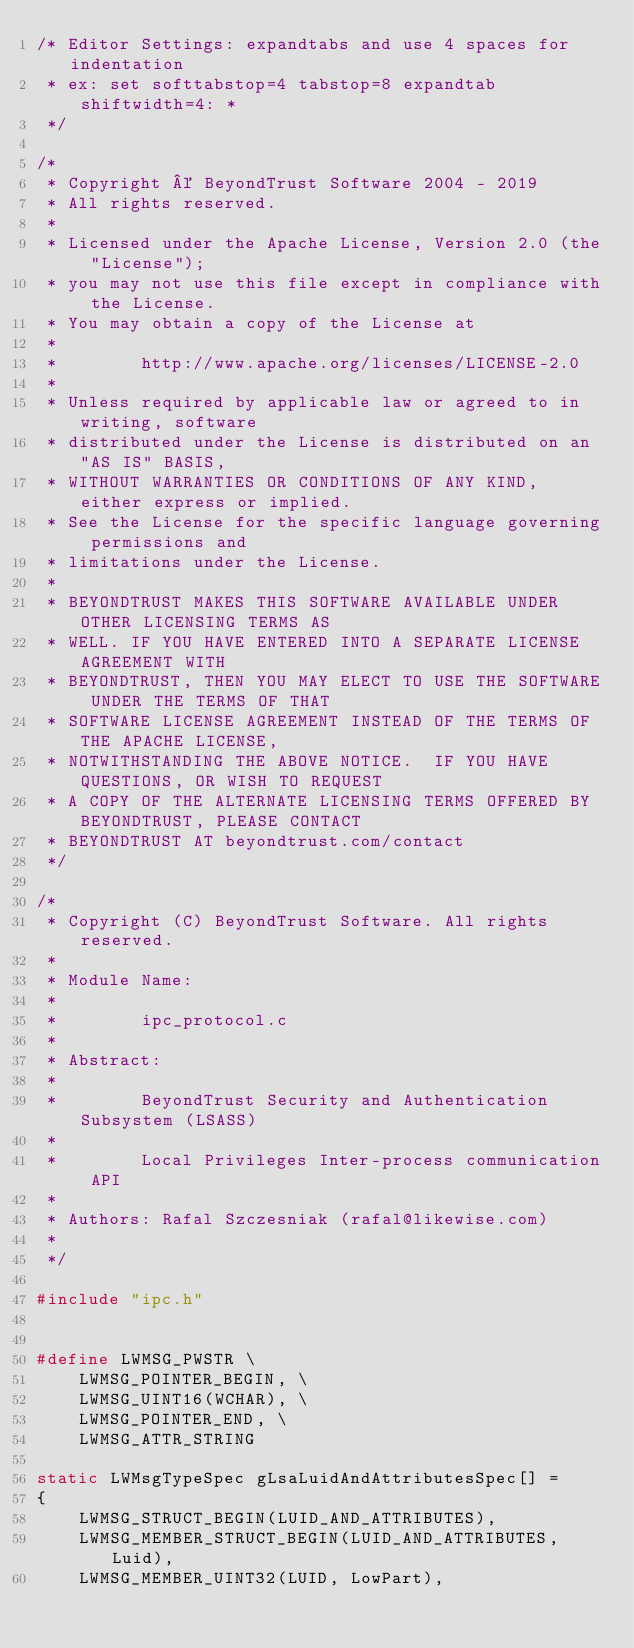Convert code to text. <code><loc_0><loc_0><loc_500><loc_500><_C_>/* Editor Settings: expandtabs and use 4 spaces for indentation
 * ex: set softtabstop=4 tabstop=8 expandtab shiftwidth=4: *
 */

/*
 * Copyright © BeyondTrust Software 2004 - 2019
 * All rights reserved.
 *
 * Licensed under the Apache License, Version 2.0 (the "License");
 * you may not use this file except in compliance with the License.
 * You may obtain a copy of the License at
 *
 *        http://www.apache.org/licenses/LICENSE-2.0
 *
 * Unless required by applicable law or agreed to in writing, software
 * distributed under the License is distributed on an "AS IS" BASIS,
 * WITHOUT WARRANTIES OR CONDITIONS OF ANY KIND, either express or implied.
 * See the License for the specific language governing permissions and
 * limitations under the License.
 *
 * BEYONDTRUST MAKES THIS SOFTWARE AVAILABLE UNDER OTHER LICENSING TERMS AS
 * WELL. IF YOU HAVE ENTERED INTO A SEPARATE LICENSE AGREEMENT WITH
 * BEYONDTRUST, THEN YOU MAY ELECT TO USE THE SOFTWARE UNDER THE TERMS OF THAT
 * SOFTWARE LICENSE AGREEMENT INSTEAD OF THE TERMS OF THE APACHE LICENSE,
 * NOTWITHSTANDING THE ABOVE NOTICE.  IF YOU HAVE QUESTIONS, OR WISH TO REQUEST
 * A COPY OF THE ALTERNATE LICENSING TERMS OFFERED BY BEYONDTRUST, PLEASE CONTACT
 * BEYONDTRUST AT beyondtrust.com/contact
 */

/*
 * Copyright (C) BeyondTrust Software. All rights reserved.
 *
 * Module Name:
 *
 *        ipc_protocol.c
 *
 * Abstract:
 *
 *        BeyondTrust Security and Authentication Subsystem (LSASS)
 *
 *        Local Privileges Inter-process communication API
 *
 * Authors: Rafal Szczesniak (rafal@likewise.com)
 *
 */

#include "ipc.h"


#define LWMSG_PWSTR \
    LWMSG_POINTER_BEGIN, \
    LWMSG_UINT16(WCHAR), \
    LWMSG_POINTER_END, \
    LWMSG_ATTR_STRING

static LWMsgTypeSpec gLsaLuidAndAttributesSpec[] =
{
    LWMSG_STRUCT_BEGIN(LUID_AND_ATTRIBUTES),
    LWMSG_MEMBER_STRUCT_BEGIN(LUID_AND_ATTRIBUTES, Luid),
    LWMSG_MEMBER_UINT32(LUID, LowPart),</code> 